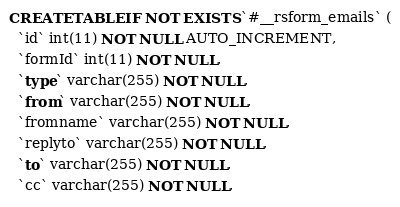Convert code to text. <code><loc_0><loc_0><loc_500><loc_500><_SQL_>CREATE TABLE IF NOT EXISTS `#__rsform_emails` (
  `id` int(11) NOT NULL AUTO_INCREMENT,
  `formId` int(11) NOT NULL,
  `type` varchar(255) NOT NULL,
  `from` varchar(255) NOT NULL,
  `fromname` varchar(255) NOT NULL,
  `replyto` varchar(255) NOT NULL,
  `to` varchar(255) NOT NULL,
  `cc` varchar(255) NOT NULL,</code> 